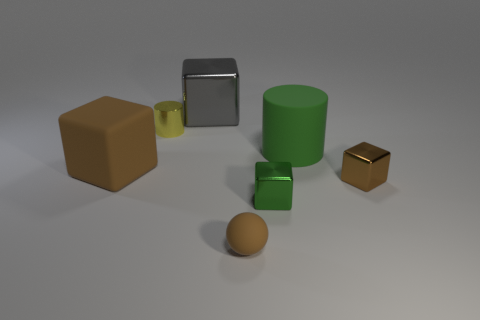There is a tiny rubber ball in front of the gray thing; what number of big rubber objects are behind it?
Ensure brevity in your answer.  2. Is there a big blue shiny cylinder?
Your answer should be compact. No. Are there any yellow cylinders made of the same material as the green cylinder?
Ensure brevity in your answer.  No. Are there more large rubber things in front of the brown metallic block than gray shiny things that are to the right of the gray metallic block?
Offer a very short reply. No. Is the size of the matte block the same as the green matte cylinder?
Give a very brief answer. Yes. What is the color of the tiny cube that is left of the cylinder that is to the right of the gray cube?
Provide a succinct answer. Green. What is the color of the large cylinder?
Provide a succinct answer. Green. Are there any matte spheres that have the same color as the rubber block?
Ensure brevity in your answer.  Yes. There is a cube behind the tiny shiny cylinder; is it the same color as the small sphere?
Your answer should be very brief. No. What number of things are either small things that are behind the big brown matte block or tiny green rubber cubes?
Offer a very short reply. 1. 